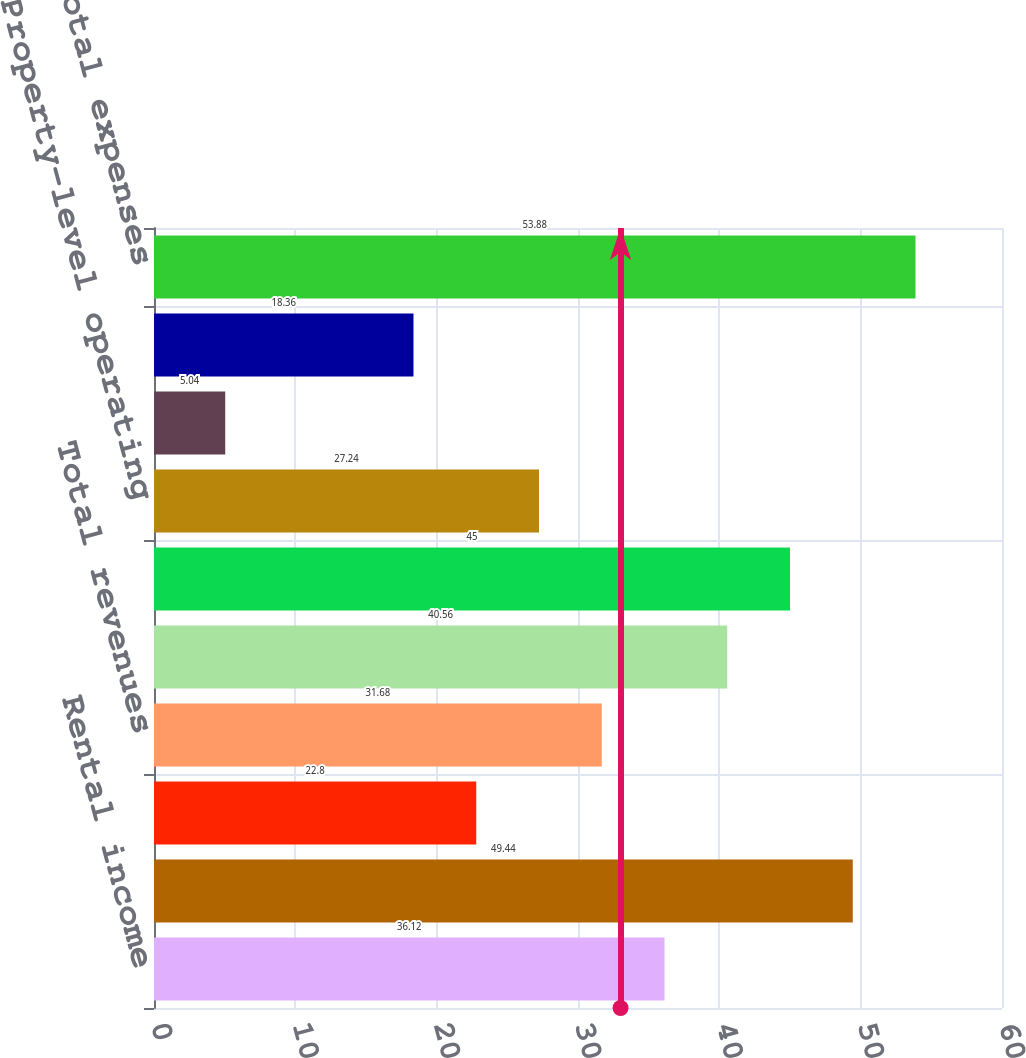<chart> <loc_0><loc_0><loc_500><loc_500><bar_chart><fcel>Rental income<fcel>Interest income from loans<fcel>Interest and other income<fcel>Total revenues<fcel>Interest<fcel>Depreciation and amortization<fcel>Property-level operating<fcel>General administrative and<fcel>Loss on extinguishment of debt<fcel>Total expenses<nl><fcel>36.12<fcel>49.44<fcel>22.8<fcel>31.68<fcel>40.56<fcel>45<fcel>27.24<fcel>5.04<fcel>18.36<fcel>53.88<nl></chart> 